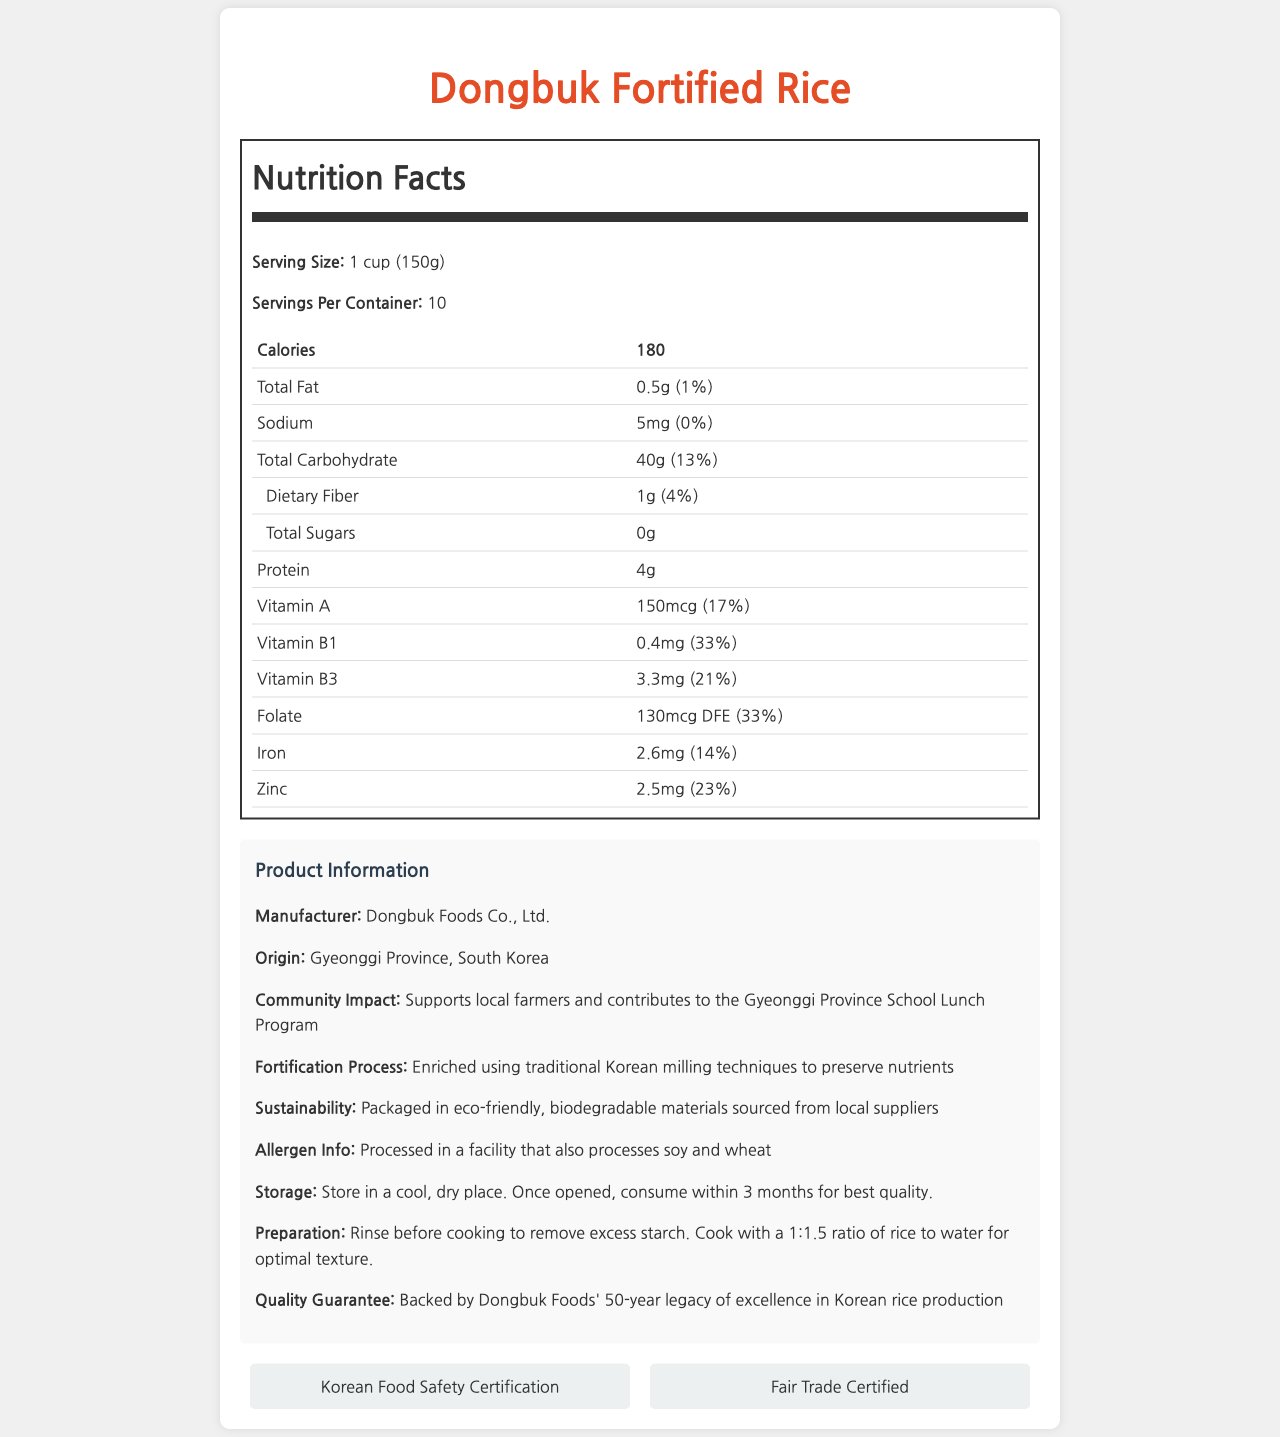what is the serving size of Dongbuk Fortified Rice? The serving size is specified under the "Nutrition Facts" section of the document.
Answer: 1 cup (150g) how many servings are there per container? The document lists "Servings Per Container: 10" under the "Nutrition Facts" section.
Answer: 10 what is the total amount of calories in one serving? The number of calories per serving is given in the "Nutrition Facts" section.
Answer: 180 calories what percentage of the daily value of Vitamin B1 does one serving provide? The document specifies the daily value percentage for Vitamin B1 as 33%.
Answer: 33% how much Zinc is in one serving? The amount of Zinc per serving is detailed as 2.5mg in the "Nutrition Facts" section.
Answer: 2.5mg which certification does Dongbuk Fortified Rice possess? A. USDA Organic B. Non-GMO Project Verified C. Fair Trade Certified The document mentions "Fair Trade Certified" under the certifications section.
Answer: C what is the company that manufactures Dongbuk Fortified Rice? A. South Korea Rice Corporation B. Dongbuk Foods Co., Ltd. C. Gyeonggi Foods Company The manufacturer is listed as "Dongbuk Foods Co., Ltd." in the product information section.
Answer: B is Dongbuk Fortified Rice gluten-free? The document does not provide any specific information about gluten or its absence.
Answer: Not enough information is the rice processed in a facility that also handles soy and wheat? The allergen information states that the rice is processed in a facility that also processes soy and wheat.
Answer: Yes describe the main idea of this document The explanation involves summarizing the purpose and the detailed content of the document which includes nutritional values, manufacturer details, certifications, and community impact.
Answer: The document provides comprehensive nutrition facts and additional information about Dongbuk Fortified Rice, highlighting its serving size, calories, nutrient contents, certifications, and impact on the local community. how long has Dongbuk Foods been committed to rice production excellence? According to the quality guarantee in the product information section, the company has a 50-year legacy of excellence in Korean rice production.
Answer: 50 years what is the suggested ratio of rice to water for cooking? The preparation suggestion states a 1:1.5 ratio of rice to water for optimal texture.
Answer: 1:1.5 what are the eco-friendly practices mentioned in the document? The sustainability statement mentions that the rice is packaged in eco-friendly materials sourced locally.
Answer: Packaged in eco-friendly, biodegradable materials sourced from local suppliers where is Dongbuk Fortified Rice originated? The document states the origin of Dongbuk Fortified Rice as "Gyeonggi Province, South Korea".
Answer: Gyeonggi Province, South Korea what community program does Dongbuk Fortified Rice support? Under community impact, the document mentions support for the Gyeonggi Province School Lunch Program.
Answer: Gyeonggi Province School Lunch Program how much dietary fiber does one serving contain? The dietary fiber content per serving is listed as 1g in the "Nutrition Facts" section.
Answer: 1g 